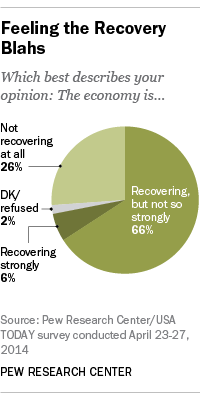Draw attention to some important aspects in this diagram. A majority of opinions were 6%, indicating a strong recovery. The total percentage of individuals who strongly recover and those who refuse to wear a mask in the event of a potential infection is 0.08. 